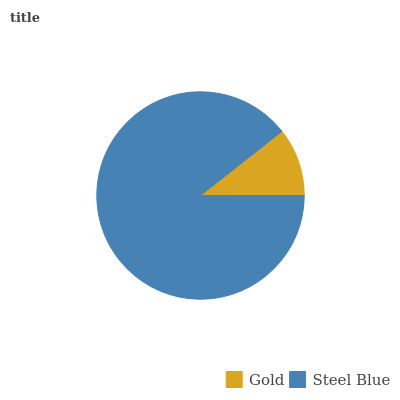Is Gold the minimum?
Answer yes or no. Yes. Is Steel Blue the maximum?
Answer yes or no. Yes. Is Steel Blue the minimum?
Answer yes or no. No. Is Steel Blue greater than Gold?
Answer yes or no. Yes. Is Gold less than Steel Blue?
Answer yes or no. Yes. Is Gold greater than Steel Blue?
Answer yes or no. No. Is Steel Blue less than Gold?
Answer yes or no. No. Is Steel Blue the high median?
Answer yes or no. Yes. Is Gold the low median?
Answer yes or no. Yes. Is Gold the high median?
Answer yes or no. No. Is Steel Blue the low median?
Answer yes or no. No. 